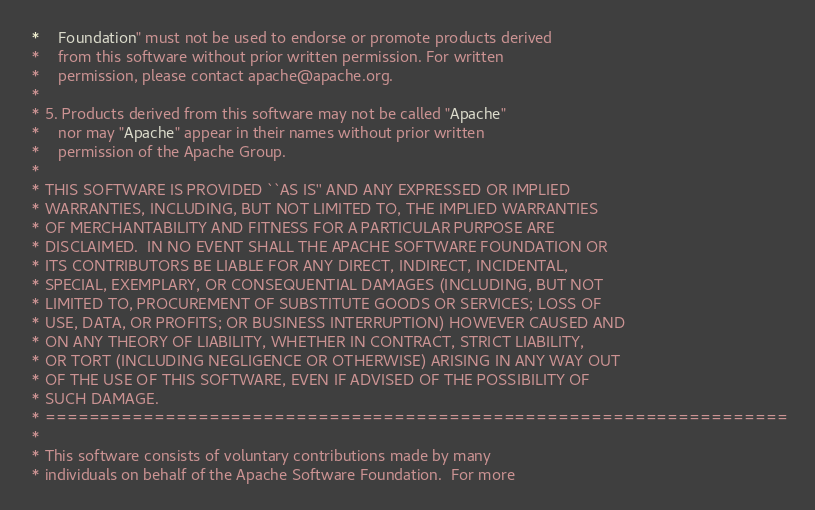<code> <loc_0><loc_0><loc_500><loc_500><_Java_> *    Foundation" must not be used to endorse or promote products derived
 *    from this software without prior written permission. For written
 *    permission, please contact apache@apache.org.
 *
 * 5. Products derived from this software may not be called "Apache"
 *    nor may "Apache" appear in their names without prior written
 *    permission of the Apache Group.
 *
 * THIS SOFTWARE IS PROVIDED ``AS IS'' AND ANY EXPRESSED OR IMPLIED
 * WARRANTIES, INCLUDING, BUT NOT LIMITED TO, THE IMPLIED WARRANTIES
 * OF MERCHANTABILITY AND FITNESS FOR A PARTICULAR PURPOSE ARE
 * DISCLAIMED.  IN NO EVENT SHALL THE APACHE SOFTWARE FOUNDATION OR
 * ITS CONTRIBUTORS BE LIABLE FOR ANY DIRECT, INDIRECT, INCIDENTAL,
 * SPECIAL, EXEMPLARY, OR CONSEQUENTIAL DAMAGES (INCLUDING, BUT NOT
 * LIMITED TO, PROCUREMENT OF SUBSTITUTE GOODS OR SERVICES; LOSS OF
 * USE, DATA, OR PROFITS; OR BUSINESS INTERRUPTION) HOWEVER CAUSED AND
 * ON ANY THEORY OF LIABILITY, WHETHER IN CONTRACT, STRICT LIABILITY,
 * OR TORT (INCLUDING NEGLIGENCE OR OTHERWISE) ARISING IN ANY WAY OUT
 * OF THE USE OF THIS SOFTWARE, EVEN IF ADVISED OF THE POSSIBILITY OF
 * SUCH DAMAGE.
 * ====================================================================
 *
 * This software consists of voluntary contributions made by many
 * individuals on behalf of the Apache Software Foundation.  For more</code> 